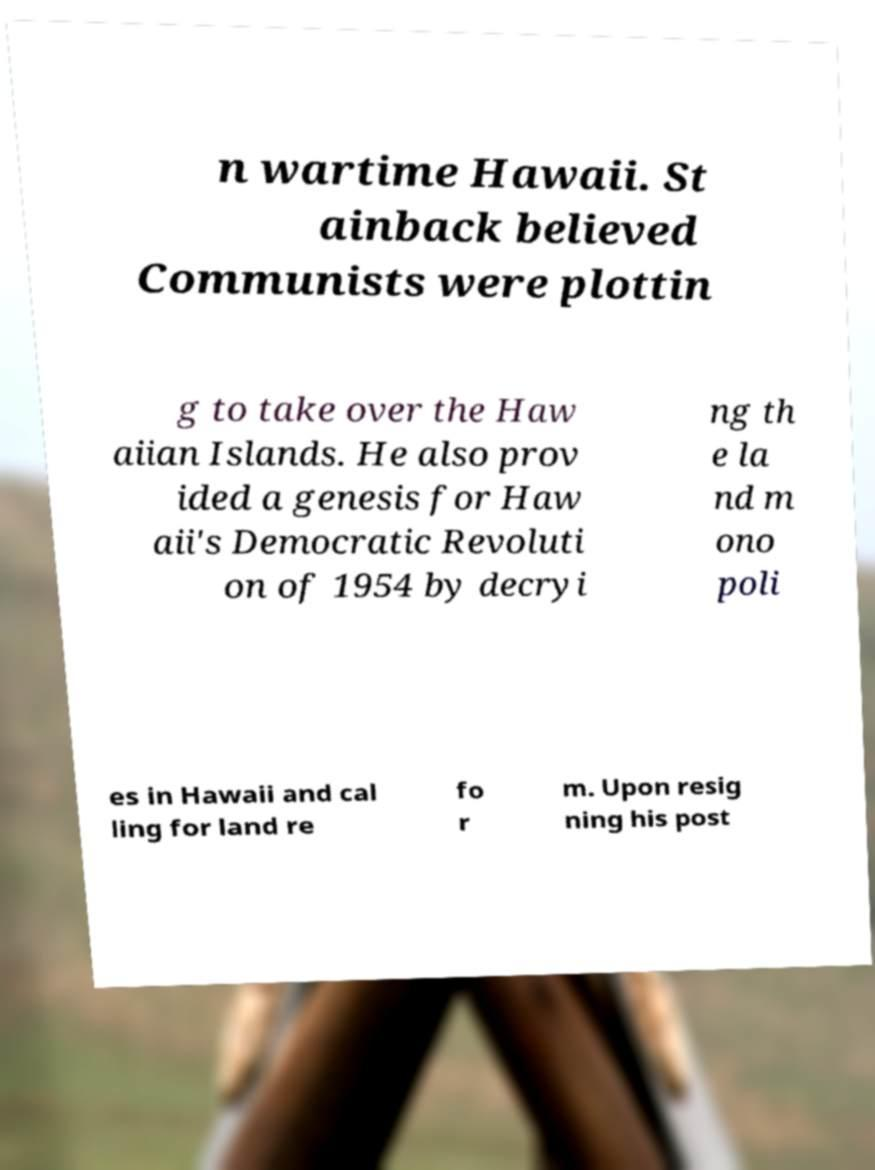Could you extract and type out the text from this image? n wartime Hawaii. St ainback believed Communists were plottin g to take over the Haw aiian Islands. He also prov ided a genesis for Haw aii's Democratic Revoluti on of 1954 by decryi ng th e la nd m ono poli es in Hawaii and cal ling for land re fo r m. Upon resig ning his post 